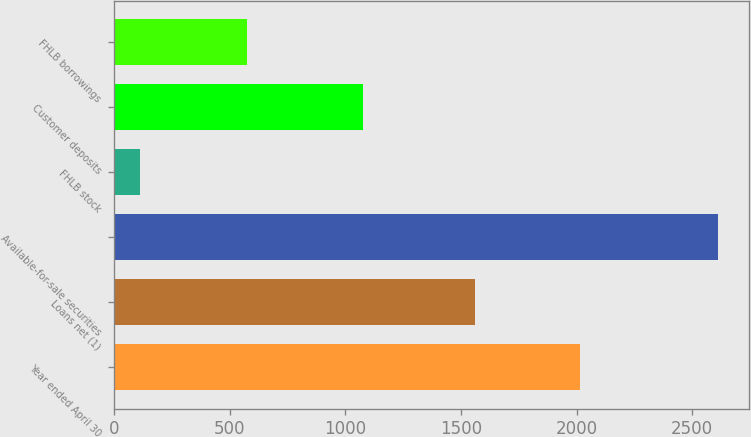Convert chart to OTSL. <chart><loc_0><loc_0><loc_500><loc_500><bar_chart><fcel>Year ended April 30<fcel>Loans net (1)<fcel>Available-for-sale securities<fcel>FHLB stock<fcel>Customer deposits<fcel>FHLB borrowings<nl><fcel>2013<fcel>1560<fcel>2613<fcel>113<fcel>1075<fcel>572<nl></chart> 